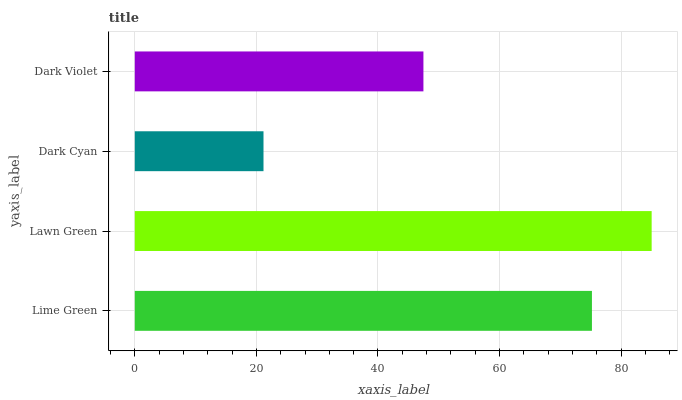Is Dark Cyan the minimum?
Answer yes or no. Yes. Is Lawn Green the maximum?
Answer yes or no. Yes. Is Lawn Green the minimum?
Answer yes or no. No. Is Dark Cyan the maximum?
Answer yes or no. No. Is Lawn Green greater than Dark Cyan?
Answer yes or no. Yes. Is Dark Cyan less than Lawn Green?
Answer yes or no. Yes. Is Dark Cyan greater than Lawn Green?
Answer yes or no. No. Is Lawn Green less than Dark Cyan?
Answer yes or no. No. Is Lime Green the high median?
Answer yes or no. Yes. Is Dark Violet the low median?
Answer yes or no. Yes. Is Lawn Green the high median?
Answer yes or no. No. Is Dark Cyan the low median?
Answer yes or no. No. 